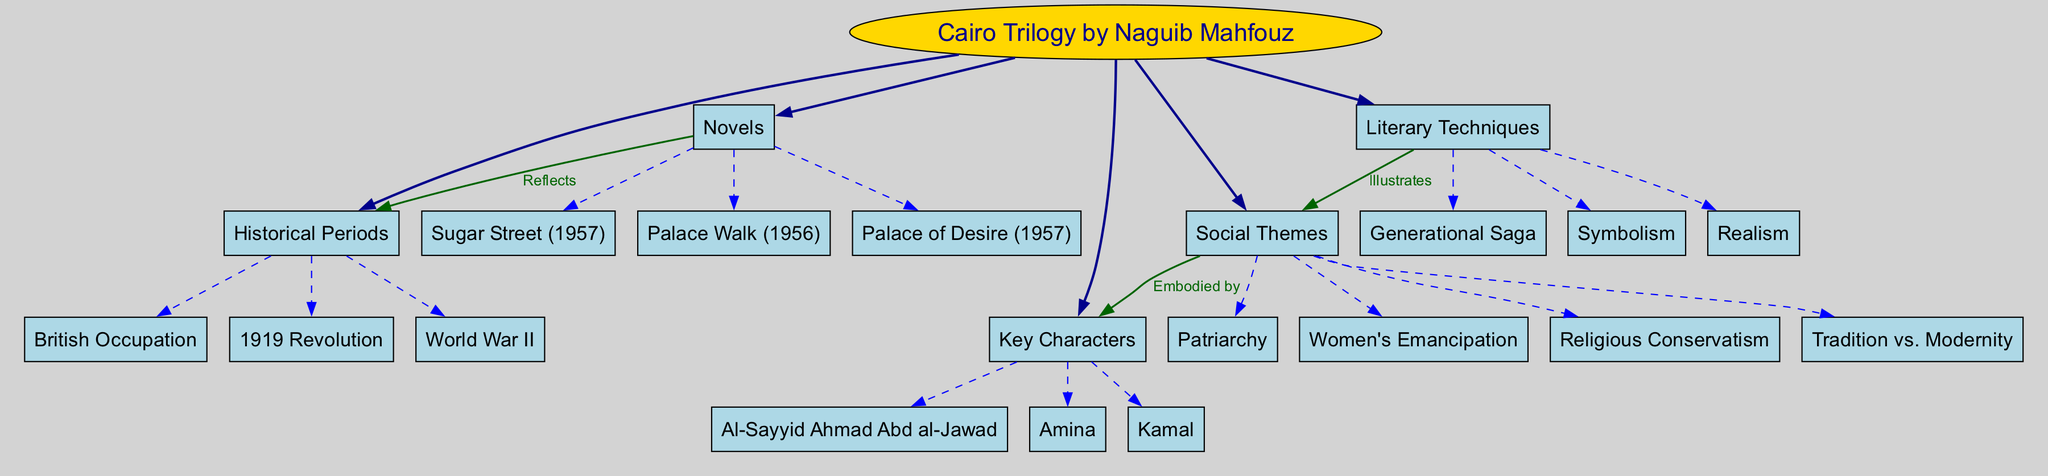What are the three novels in the Cairo Trilogy? The diagram lists three sub-branches under the "Novels" main branch: "Palace Walk," "Palace of Desire," and "Sugar Street."
Answer: Palace Walk, Palace of Desire, Sugar Street Which historical period is shown in the diagram? The diagram includes one of the main branches labeled "Historical Periods," with sub-branches including "British Occupation," "1919 Revolution," and "World War II."
Answer: British Occupation, 1919 Revolution, World War II How many social themes are present in the diagram? Under the "Social Themes" main branch, there are four sub-branches listed: "Tradition vs. Modernity," "Patriarchy," "Women's Emancipation," and "Religious Conservatism," indicating that there are four themes.
Answer: 4 Who is the key character associated with the tradition theme? The "Social Themes" branch indicates multiple themes, and the next branches show "Key Characters." The character "Amina" is often associated with traditional roles in the society depicted.
Answer: Amina Which literary technique is used to illustrate social themes? The diagram shows a connection from the "Literary Techniques" branch to the "Social Themes" branch, indicating that literary techniques illustrate these themes. The specific technique mentioned is "Realism."
Answer: Realism How do "Novels" reflect "Historical Periods"? The diagram explicitly indicates a connection between the main branches "Novels" and "Historical Periods," illustrating that the novels reflect the historical context described in those periods.
Answer: Reflects Which character embodies feminist themes in the trilogy? By analyzing the connections between "Social Themes" and "Key Characters," Amina is depicted in themes related to "Women's Emancipation," showcasing her role in representing feminist concerns.
Answer: Amina What is the relationship between "Literary Techniques" and "Social Themes"? The diagram illustrates a direct connection from "Literary Techniques" to "Social Themes," indicating that various literary techniques serve to illustrate the complexities of the themes discussed.
Answer: Illustrates How many main branches does the diagram present? The diagram presents five main branches: "Novels," "Historical Periods," "Social Themes," "Key Characters," and "Literary Techniques." Hence, the total is five.
Answer: 5 